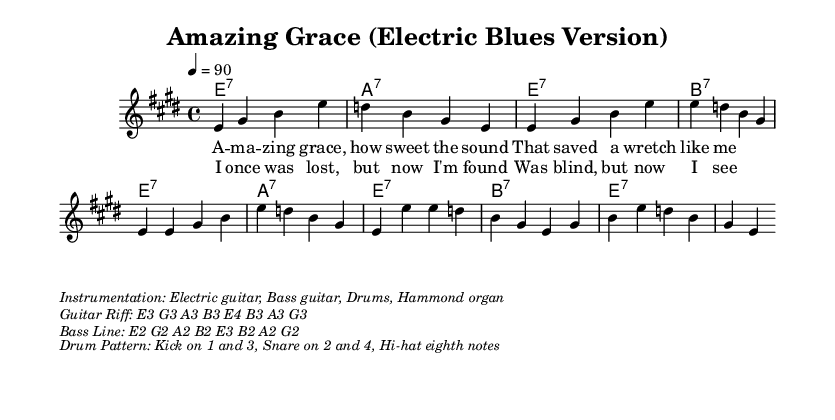What is the key signature of this music? The key signature is E major, which has four sharps: F#, C#, G#, and D#. This can be inferred from the 'global' section where \key e \major is defined.
Answer: E major What is the time signature of this music? The time signature is 4/4, indicated in the 'global' section by \time 4/4. This means there are four beats in each measure and the quarter note gets one beat.
Answer: 4/4 What is the tempo marking of this piece? The tempo marking is 90 beats per minute, indicated by the directive 4 = 90 in the 'global' section, which specifies the speed of the music.
Answer: 90 How many measures are present in the provided melody? The melody consists of a total of 12 measures, which can be visually counted by looking at how the notes are grouped within the melody section. Each line typically contains a consistent number of beats that correspond to measures.
Answer: 12 measures What instrumentation is indicated in the sheet music? The instrumentation specified in the markup section includes electric guitar, bass guitar, drums, and Hammond organ. This is detailed in the text following the music notations.
Answer: Electric guitar, Bass guitar, Drums, Hammond organ What is the first lyric in the verse? The first lyric in the verse is "Amazing grace," shown in the verseOne lyrics section, indicating the opening of the song as it is sung.
Answer: Amazing grace What is the guitar riff provided in the markup? The guitar riff consists of the notes E3, G3, A3, B3, E4, B3, A3, G3, listed in the corresponding markup section, which gives specific notes for guitarists to play.
Answer: E3 G3 A3 B3 E4 B3 A3 G3 